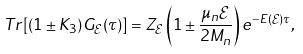<formula> <loc_0><loc_0><loc_500><loc_500>T r [ ( 1 \pm K _ { 3 } ) G _ { \mathcal { E } } ( \tau ) ] = Z _ { \mathcal { E } } \left ( 1 \pm \frac { \mu _ { n } \mathcal { E } } { 2 M _ { n } } \right ) e ^ { - E ( \mathcal { E } ) \tau } ,</formula> 